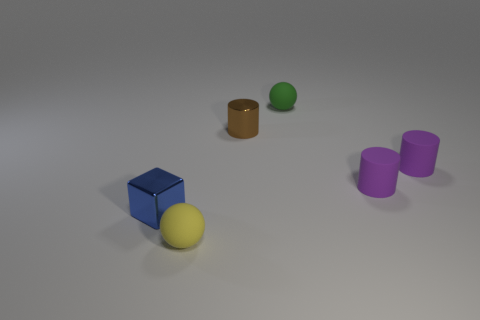Add 3 tiny purple cylinders. How many objects exist? 9 Subtract all spheres. How many objects are left? 4 Add 1 purple objects. How many purple objects exist? 3 Subtract 0 brown cubes. How many objects are left? 6 Subtract all blue shiny cubes. Subtract all large green shiny balls. How many objects are left? 5 Add 1 tiny things. How many tiny things are left? 7 